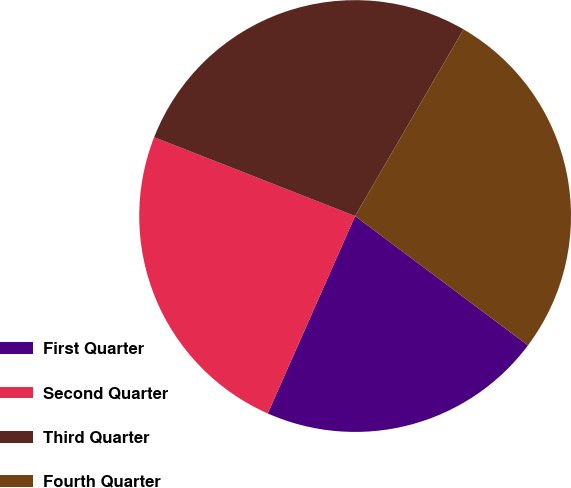Convert chart. <chart><loc_0><loc_0><loc_500><loc_500><pie_chart><fcel>First Quarter<fcel>Second Quarter<fcel>Third Quarter<fcel>Fourth Quarter<nl><fcel>21.41%<fcel>24.32%<fcel>27.43%<fcel>26.85%<nl></chart> 